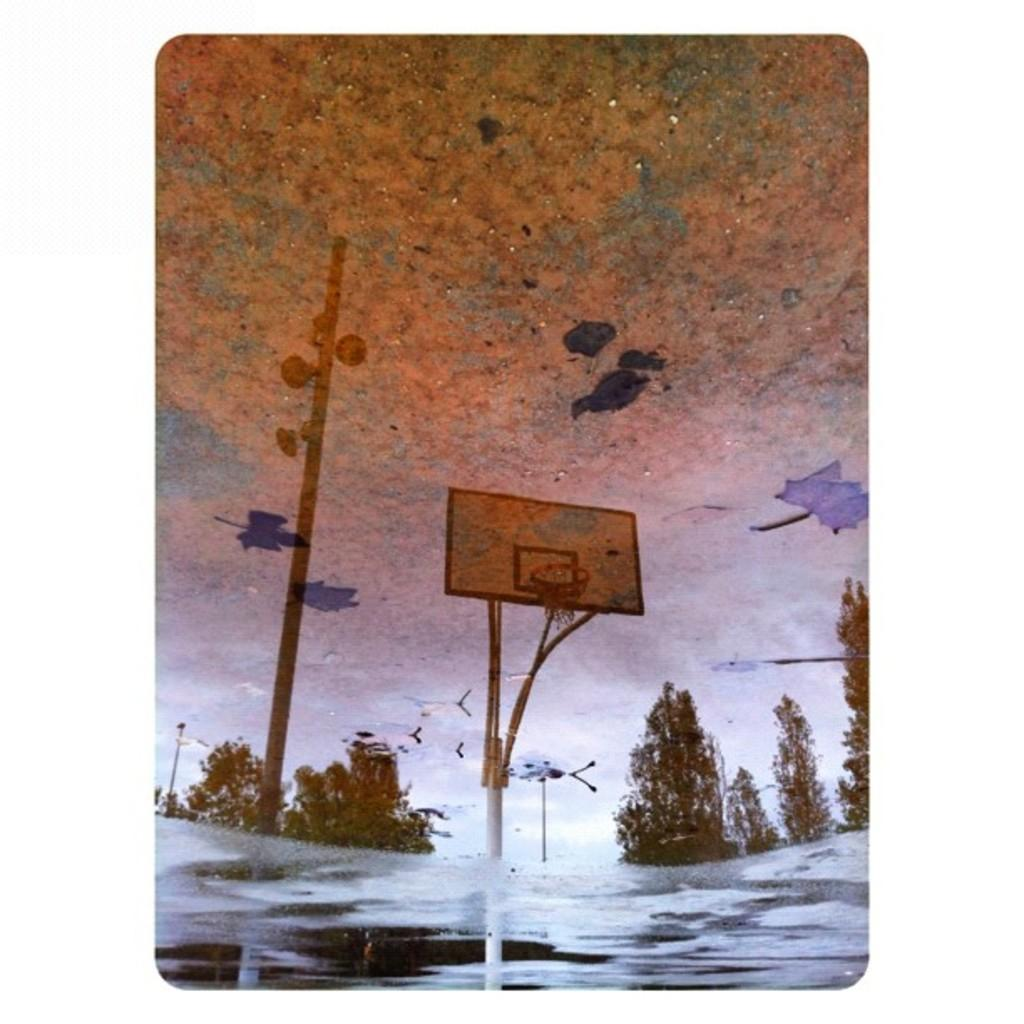What type of artwork is shown in the image? The image appears to be a painting. What is the subject of the painting? The painting depicts a basketball court. Are there any basketball-related features in the painting? Yes, there is a basketball board present. What can be seen in the background of the painting? Trees are visible around the basketball court. What structures are present in the painting? Light poles are present. What is the condition of the ground in the painting? There is ice on the ground. What type of business is being conducted on the basketball court in the painting? There is no indication of any business being conducted in the painting; it depicts a basketball court with a basketball board and ice on the ground. How many rings are visible on the basketball board in the painting? There is only one basketball board visible in the painting, and it has one ring. 